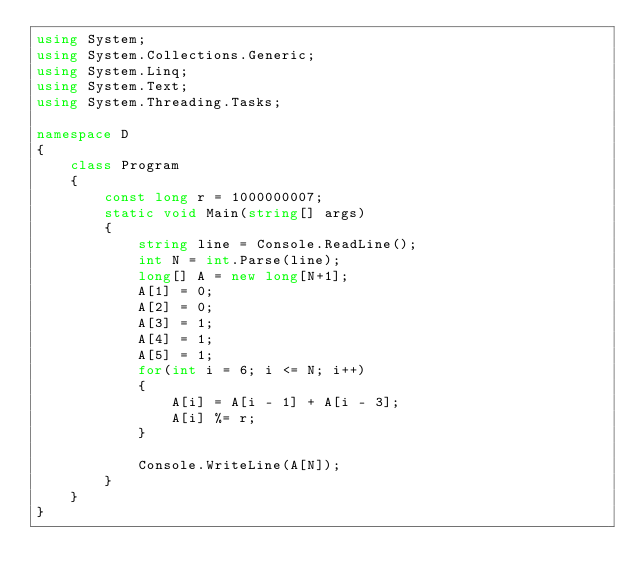<code> <loc_0><loc_0><loc_500><loc_500><_C#_>using System;
using System.Collections.Generic;
using System.Linq;
using System.Text;
using System.Threading.Tasks;

namespace D
{
    class Program
    {
        const long r = 1000000007;
        static void Main(string[] args)
        {
            string line = Console.ReadLine();
            int N = int.Parse(line);
            long[] A = new long[N+1];
            A[1] = 0;
            A[2] = 0;
            A[3] = 1;
            A[4] = 1;
            A[5] = 1;
            for(int i = 6; i <= N; i++)
            {
                A[i] = A[i - 1] + A[i - 3];
                A[i] %= r;
            }

            Console.WriteLine(A[N]);
        }
    }
}
</code> 